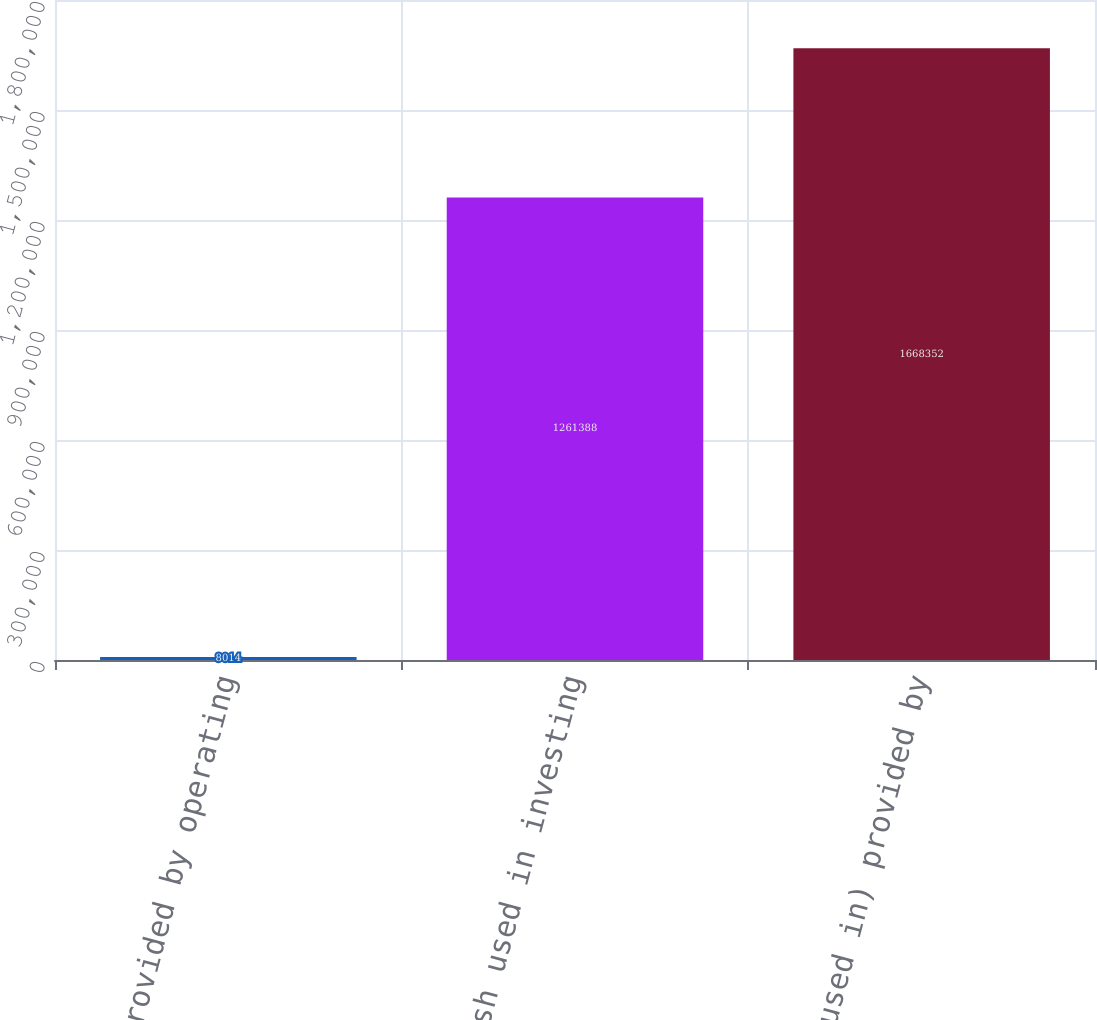<chart> <loc_0><loc_0><loc_500><loc_500><bar_chart><fcel>Net cash provided by operating<fcel>Net cash used in investing<fcel>Net cash (used in) provided by<nl><fcel>8014<fcel>1.26139e+06<fcel>1.66835e+06<nl></chart> 